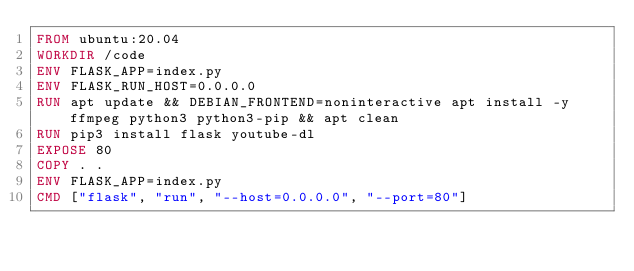Convert code to text. <code><loc_0><loc_0><loc_500><loc_500><_Dockerfile_>FROM ubuntu:20.04
WORKDIR /code
ENV FLASK_APP=index.py
ENV FLASK_RUN_HOST=0.0.0.0
RUN apt update && DEBIAN_FRONTEND=noninteractive apt install -y ffmpeg python3 python3-pip && apt clean
RUN pip3 install flask youtube-dl
EXPOSE 80
COPY . .
ENV FLASK_APP=index.py
CMD ["flask", "run", "--host=0.0.0.0", "--port=80"]
</code> 